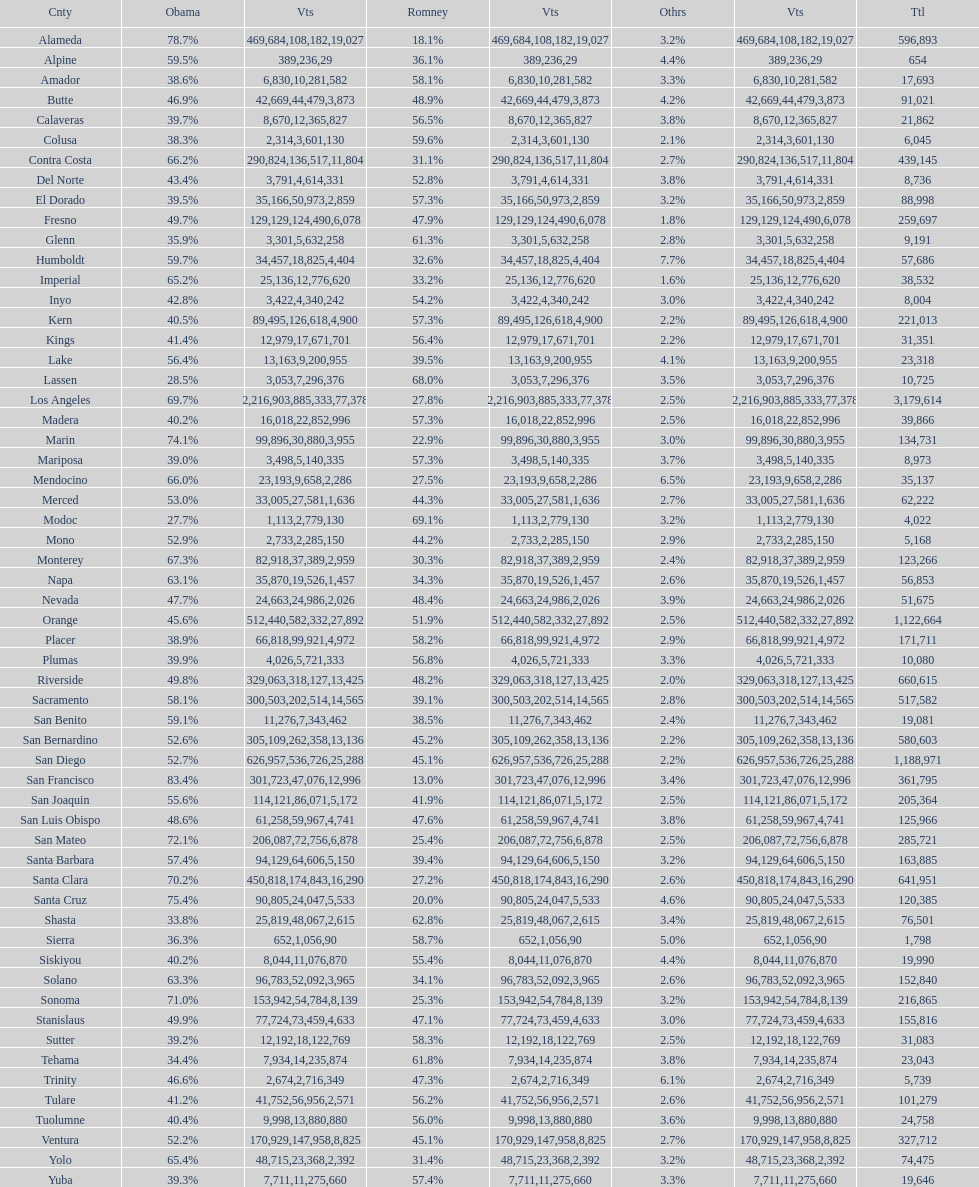In which county were the highest number of total votes recorded? Los Angeles. 